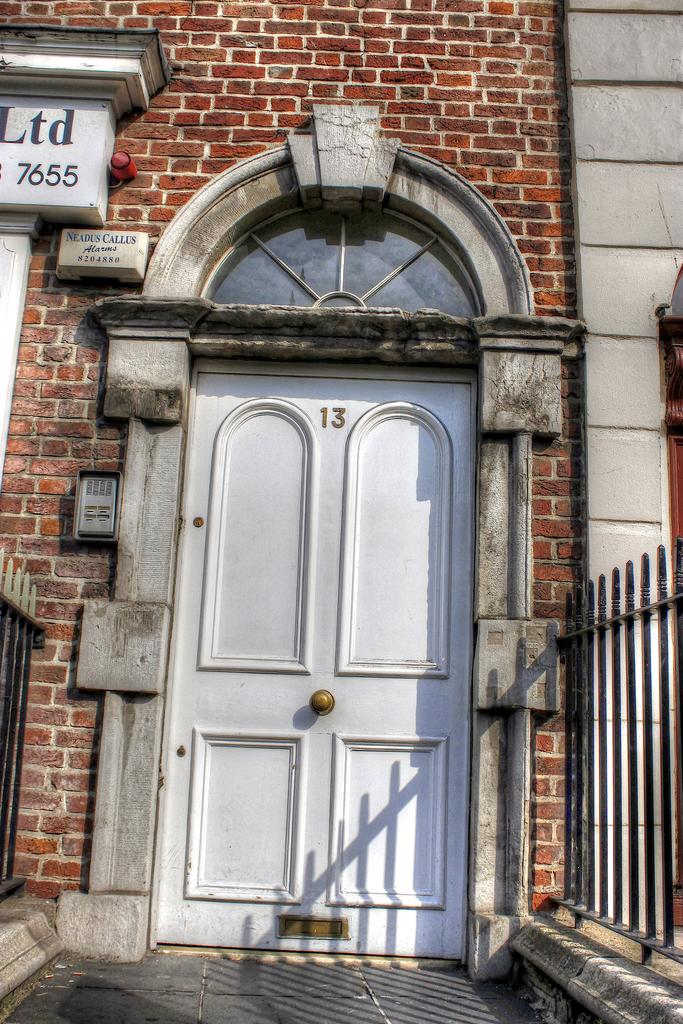What is the primary object in the image? There is a door in the image. What color is the door? The door is white. What is located next to the door? There is railing next to the door. What can be seen in the background of the image? There is a brown color brick wall in the background. What is to the left of the door? There is a board to the left of the door. How does the pollution affect the slope in the image? There is no pollution or slope present in the image; it features a door, railing, a brick wall, and a board. 